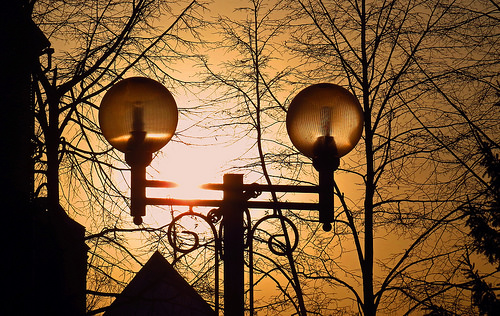<image>
Is the lamp under the tree? Yes. The lamp is positioned underneath the tree, with the tree above it in the vertical space. Is the light behind the pole? No. The light is not behind the pole. From this viewpoint, the light appears to be positioned elsewhere in the scene. 